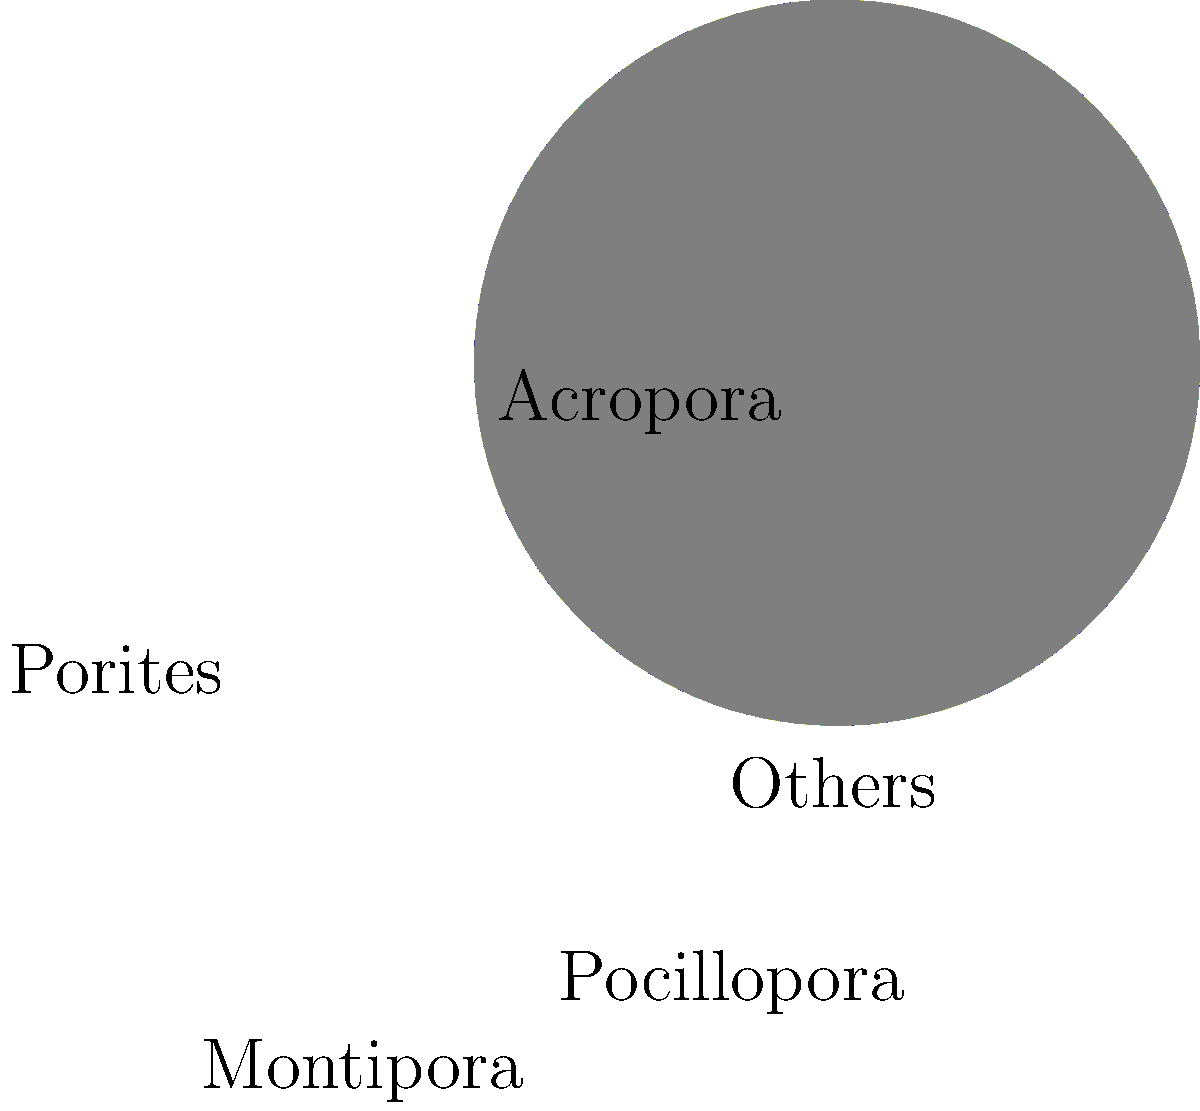Based on the pie chart showing the distribution of coral species in a reef ecosystem, which two genera together account for 60% of the coral cover? How might this distribution impact the reef's resilience to environmental stressors, considering the ecological roles of these dominant species? To answer this question, we need to analyze the pie chart and understand the ecological implications of the species distribution:

1. Identify the two largest segments in the pie chart:
   - Acropora: 35%
   - Porites: 25%

2. Calculate their combined percentage:
   35% + 25% = 60%

3. Ecological implications:
   a) Acropora:
      - Fast-growing, branching corals
      - Provide complex habitat for reef fish
      - More susceptible to bleaching and physical damage

   b) Porites:
      - Slow-growing, massive corals
      - More resistant to bleaching and physical damage
      - Important for reef structure and long-term stability

4. Reef resilience assessment:
   - Dominance of Acropora (35%) suggests:
     * High productivity and habitat complexity
     * Potentially faster recovery after disturbances
     * Higher vulnerability to climate change and ocean acidification

   - Significant presence of Porites (25%) indicates:
     * Enhanced structural stability
     * Increased resilience to some environmental stressors
     * Slower recovery rates after major disturbances

5. Overall impact on reef resilience:
   The combination of fast-growing Acropora and resilient Porites provides a balance between rapid growth and long-term stability. This diversity in growth forms and stress tolerance may enhance the reef's overall resilience to various environmental stressors, although the high proportion of Acropora still leaves the reef vulnerable to large-scale bleaching events and other acute disturbances.
Answer: Acropora and Porites; balanced resilience with potential vulnerability to acute disturbances. 